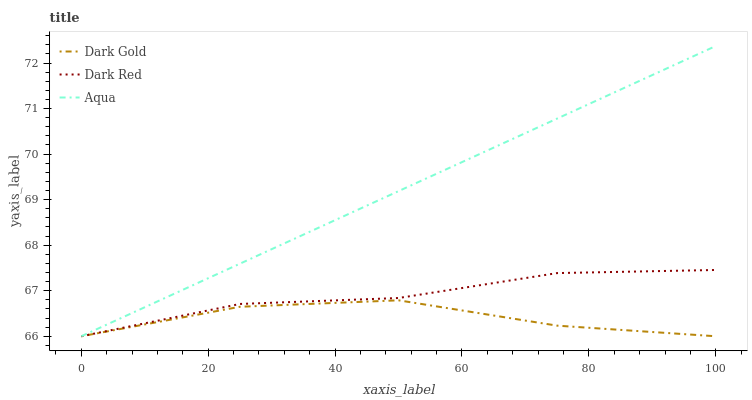Does Dark Gold have the minimum area under the curve?
Answer yes or no. Yes. Does Aqua have the maximum area under the curve?
Answer yes or no. Yes. Does Aqua have the minimum area under the curve?
Answer yes or no. No. Does Dark Gold have the maximum area under the curve?
Answer yes or no. No. Is Aqua the smoothest?
Answer yes or no. Yes. Is Dark Gold the roughest?
Answer yes or no. Yes. Is Dark Gold the smoothest?
Answer yes or no. No. Is Aqua the roughest?
Answer yes or no. No. Does Dark Red have the lowest value?
Answer yes or no. Yes. Does Aqua have the highest value?
Answer yes or no. Yes. Does Dark Gold have the highest value?
Answer yes or no. No. Does Dark Gold intersect Aqua?
Answer yes or no. Yes. Is Dark Gold less than Aqua?
Answer yes or no. No. Is Dark Gold greater than Aqua?
Answer yes or no. No. 